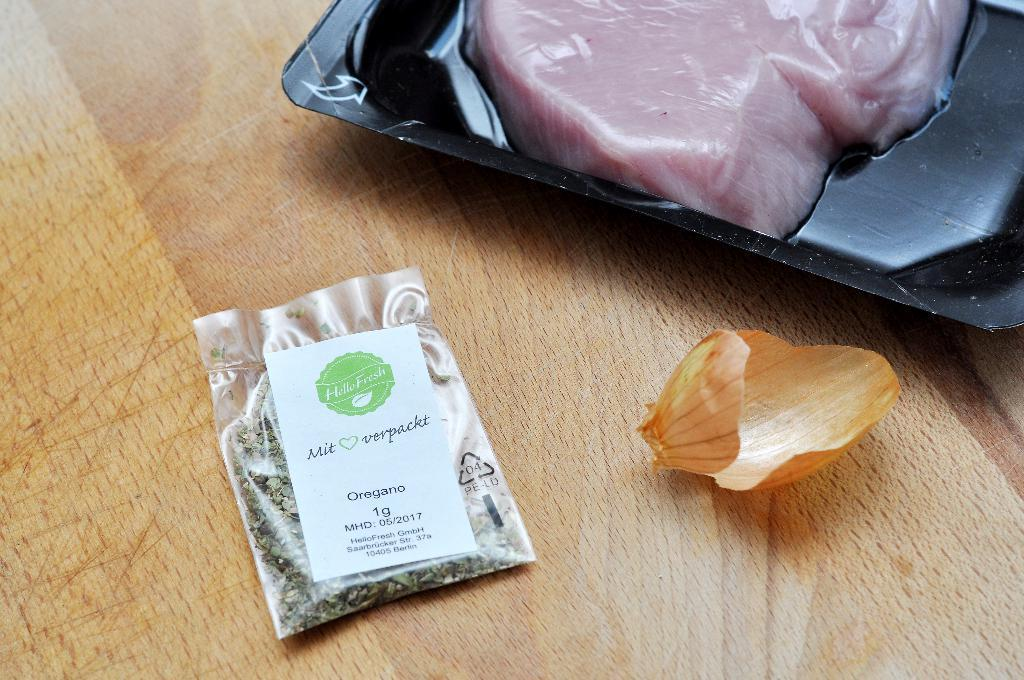What piece of furniture is visible in the image? There is a table in the image. What is placed on the table? There is a tray on the table. What is on the tray? The tray contains meat. What else can be seen on the table? There is a packet on the table. What type of vegetable is represented by its peel on the table? The peel of an onion is present on the table. How many thumbs are visible in the image? There are no thumbs visible in the image. What type of party is being held in the image? There is no party depicted in the image. 